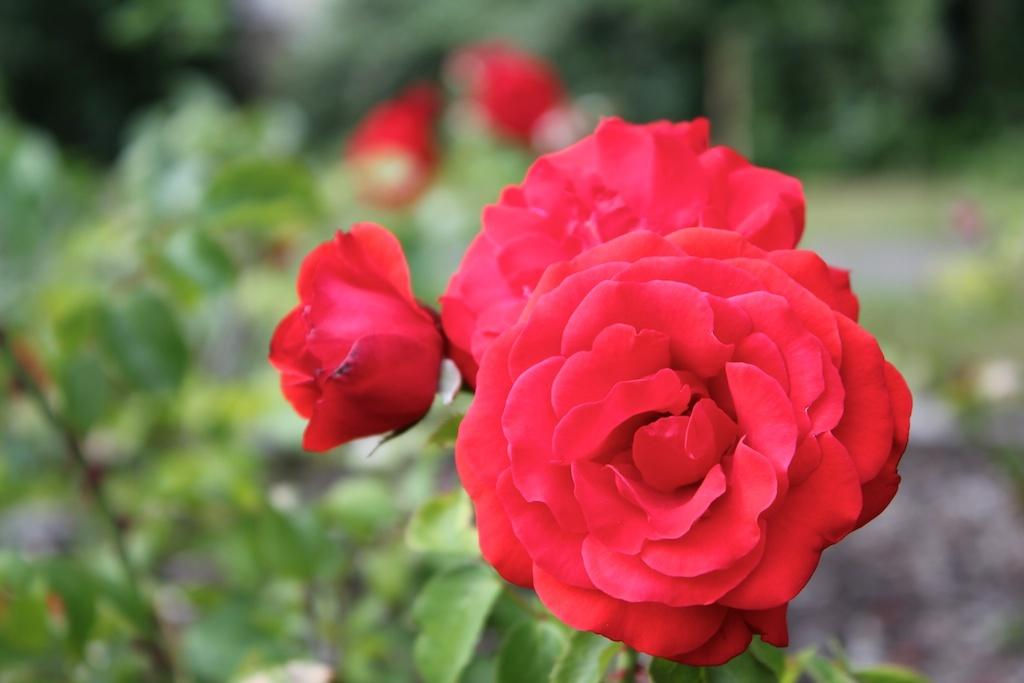What type of flowers can be seen in the image? There are red color rose flowers in the image. What other living organisms are present in the image? There are plants in the image. What can be seen in the background of the image? There are trees in the background of the image. What type of card is being used to hold the pie in the image? There is no card or pie present in the image; it features red color rose flowers and plants. Can you see a robin perched on one of the trees in the background? There is no robin present in the image; it only features red color rose flowers, plants, and trees. 